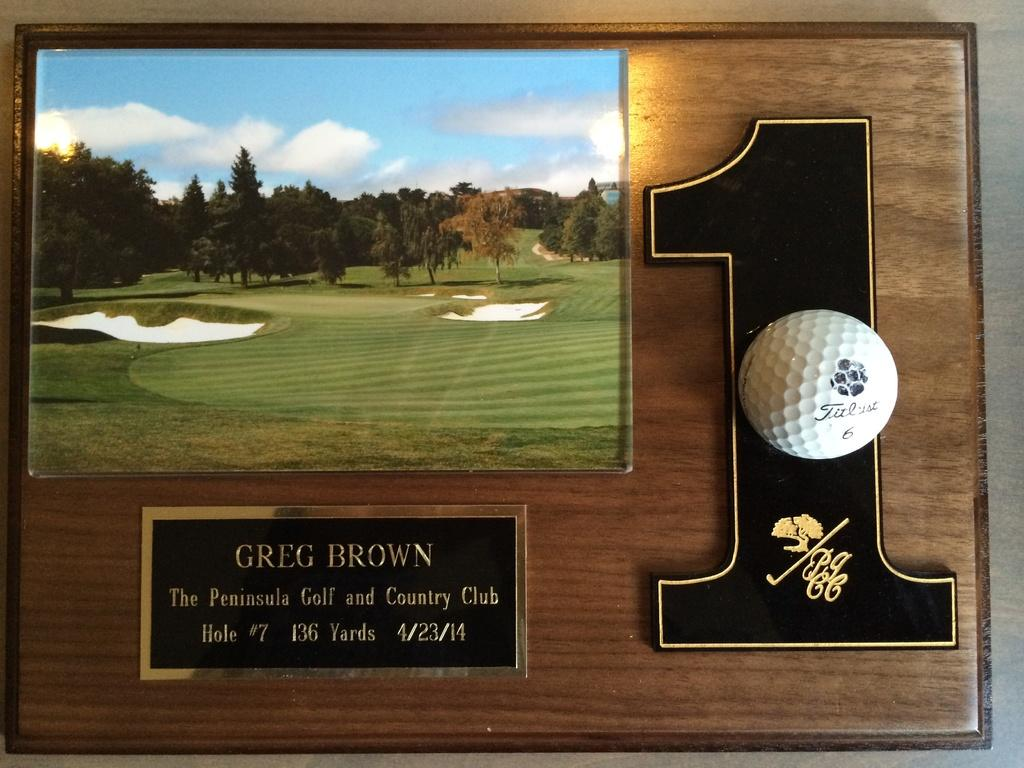<image>
Present a compact description of the photo's key features. A first place award for Greg Brown in golf 